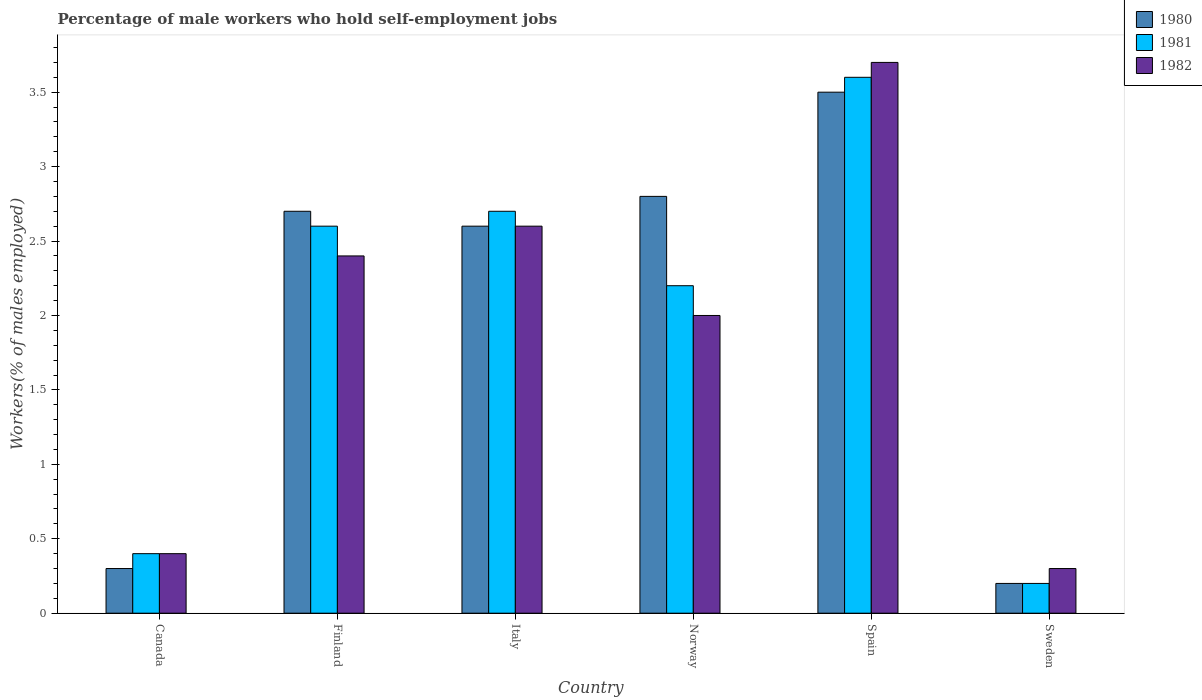How many groups of bars are there?
Offer a very short reply. 6. How many bars are there on the 2nd tick from the left?
Give a very brief answer. 3. How many bars are there on the 2nd tick from the right?
Offer a very short reply. 3. What is the label of the 6th group of bars from the left?
Keep it short and to the point. Sweden. In how many cases, is the number of bars for a given country not equal to the number of legend labels?
Make the answer very short. 0. What is the percentage of self-employed male workers in 1982 in Sweden?
Provide a succinct answer. 0.3. Across all countries, what is the maximum percentage of self-employed male workers in 1982?
Offer a very short reply. 3.7. Across all countries, what is the minimum percentage of self-employed male workers in 1981?
Provide a succinct answer. 0.2. In which country was the percentage of self-employed male workers in 1981 minimum?
Provide a succinct answer. Sweden. What is the total percentage of self-employed male workers in 1982 in the graph?
Make the answer very short. 11.4. What is the average percentage of self-employed male workers in 1982 per country?
Offer a very short reply. 1.9. What is the difference between the percentage of self-employed male workers of/in 1982 and percentage of self-employed male workers of/in 1980 in Sweden?
Your answer should be compact. 0.1. In how many countries, is the percentage of self-employed male workers in 1980 greater than 3.6 %?
Offer a terse response. 0. What is the ratio of the percentage of self-employed male workers in 1982 in Italy to that in Spain?
Provide a succinct answer. 0.7. What is the difference between the highest and the second highest percentage of self-employed male workers in 1980?
Give a very brief answer. -0.1. What is the difference between the highest and the lowest percentage of self-employed male workers in 1980?
Your answer should be very brief. 3.3. In how many countries, is the percentage of self-employed male workers in 1982 greater than the average percentage of self-employed male workers in 1982 taken over all countries?
Keep it short and to the point. 4. Is the sum of the percentage of self-employed male workers in 1982 in Finland and Norway greater than the maximum percentage of self-employed male workers in 1981 across all countries?
Make the answer very short. Yes. What does the 1st bar from the left in Sweden represents?
Your answer should be compact. 1980. What does the 2nd bar from the right in Spain represents?
Give a very brief answer. 1981. Is it the case that in every country, the sum of the percentage of self-employed male workers in 1982 and percentage of self-employed male workers in 1981 is greater than the percentage of self-employed male workers in 1980?
Provide a succinct answer. Yes. How many bars are there?
Make the answer very short. 18. What is the difference between two consecutive major ticks on the Y-axis?
Your answer should be compact. 0.5. Are the values on the major ticks of Y-axis written in scientific E-notation?
Make the answer very short. No. How many legend labels are there?
Provide a short and direct response. 3. What is the title of the graph?
Offer a very short reply. Percentage of male workers who hold self-employment jobs. Does "1962" appear as one of the legend labels in the graph?
Provide a succinct answer. No. What is the label or title of the Y-axis?
Provide a succinct answer. Workers(% of males employed). What is the Workers(% of males employed) of 1980 in Canada?
Your answer should be compact. 0.3. What is the Workers(% of males employed) of 1981 in Canada?
Your answer should be very brief. 0.4. What is the Workers(% of males employed) of 1982 in Canada?
Give a very brief answer. 0.4. What is the Workers(% of males employed) of 1980 in Finland?
Your response must be concise. 2.7. What is the Workers(% of males employed) of 1981 in Finland?
Your answer should be very brief. 2.6. What is the Workers(% of males employed) of 1982 in Finland?
Offer a very short reply. 2.4. What is the Workers(% of males employed) in 1980 in Italy?
Make the answer very short. 2.6. What is the Workers(% of males employed) in 1981 in Italy?
Offer a terse response. 2.7. What is the Workers(% of males employed) in 1982 in Italy?
Provide a succinct answer. 2.6. What is the Workers(% of males employed) in 1980 in Norway?
Offer a very short reply. 2.8. What is the Workers(% of males employed) in 1981 in Norway?
Provide a short and direct response. 2.2. What is the Workers(% of males employed) of 1982 in Norway?
Give a very brief answer. 2. What is the Workers(% of males employed) of 1981 in Spain?
Provide a succinct answer. 3.6. What is the Workers(% of males employed) in 1982 in Spain?
Your answer should be very brief. 3.7. What is the Workers(% of males employed) in 1980 in Sweden?
Provide a short and direct response. 0.2. What is the Workers(% of males employed) of 1981 in Sweden?
Provide a short and direct response. 0.2. What is the Workers(% of males employed) in 1982 in Sweden?
Make the answer very short. 0.3. Across all countries, what is the maximum Workers(% of males employed) in 1980?
Your answer should be compact. 3.5. Across all countries, what is the maximum Workers(% of males employed) of 1981?
Ensure brevity in your answer.  3.6. Across all countries, what is the maximum Workers(% of males employed) in 1982?
Make the answer very short. 3.7. Across all countries, what is the minimum Workers(% of males employed) of 1980?
Make the answer very short. 0.2. Across all countries, what is the minimum Workers(% of males employed) of 1981?
Offer a very short reply. 0.2. Across all countries, what is the minimum Workers(% of males employed) of 1982?
Your answer should be very brief. 0.3. What is the total Workers(% of males employed) in 1981 in the graph?
Make the answer very short. 11.7. What is the difference between the Workers(% of males employed) of 1981 in Canada and that in Norway?
Ensure brevity in your answer.  -1.8. What is the difference between the Workers(% of males employed) in 1980 in Canada and that in Spain?
Make the answer very short. -3.2. What is the difference between the Workers(% of males employed) in 1980 in Canada and that in Sweden?
Provide a succinct answer. 0.1. What is the difference between the Workers(% of males employed) in 1981 in Canada and that in Sweden?
Your response must be concise. 0.2. What is the difference between the Workers(% of males employed) in 1980 in Finland and that in Italy?
Ensure brevity in your answer.  0.1. What is the difference between the Workers(% of males employed) in 1981 in Finland and that in Italy?
Give a very brief answer. -0.1. What is the difference between the Workers(% of males employed) in 1982 in Finland and that in Italy?
Your answer should be very brief. -0.2. What is the difference between the Workers(% of males employed) in 1981 in Finland and that in Spain?
Provide a short and direct response. -1. What is the difference between the Workers(% of males employed) of 1980 in Finland and that in Sweden?
Keep it short and to the point. 2.5. What is the difference between the Workers(% of males employed) of 1981 in Italy and that in Spain?
Provide a short and direct response. -0.9. What is the difference between the Workers(% of males employed) of 1982 in Italy and that in Spain?
Provide a succinct answer. -1.1. What is the difference between the Workers(% of males employed) in 1982 in Italy and that in Sweden?
Provide a succinct answer. 2.3. What is the difference between the Workers(% of males employed) of 1980 in Norway and that in Spain?
Your answer should be compact. -0.7. What is the difference between the Workers(% of males employed) in 1981 in Norway and that in Spain?
Ensure brevity in your answer.  -1.4. What is the difference between the Workers(% of males employed) in 1982 in Norway and that in Spain?
Offer a very short reply. -1.7. What is the difference between the Workers(% of males employed) of 1982 in Norway and that in Sweden?
Keep it short and to the point. 1.7. What is the difference between the Workers(% of males employed) in 1980 in Spain and that in Sweden?
Make the answer very short. 3.3. What is the difference between the Workers(% of males employed) of 1981 in Spain and that in Sweden?
Ensure brevity in your answer.  3.4. What is the difference between the Workers(% of males employed) of 1982 in Spain and that in Sweden?
Your answer should be compact. 3.4. What is the difference between the Workers(% of males employed) in 1980 in Canada and the Workers(% of males employed) in 1981 in Finland?
Keep it short and to the point. -2.3. What is the difference between the Workers(% of males employed) of 1980 in Canada and the Workers(% of males employed) of 1981 in Italy?
Your answer should be very brief. -2.4. What is the difference between the Workers(% of males employed) in 1980 in Canada and the Workers(% of males employed) in 1981 in Norway?
Your answer should be compact. -1.9. What is the difference between the Workers(% of males employed) of 1981 in Canada and the Workers(% of males employed) of 1982 in Norway?
Make the answer very short. -1.6. What is the difference between the Workers(% of males employed) of 1980 in Canada and the Workers(% of males employed) of 1982 in Spain?
Keep it short and to the point. -3.4. What is the difference between the Workers(% of males employed) in 1981 in Canada and the Workers(% of males employed) in 1982 in Spain?
Your answer should be very brief. -3.3. What is the difference between the Workers(% of males employed) of 1980 in Canada and the Workers(% of males employed) of 1981 in Sweden?
Keep it short and to the point. 0.1. What is the difference between the Workers(% of males employed) of 1980 in Finland and the Workers(% of males employed) of 1982 in Italy?
Offer a terse response. 0.1. What is the difference between the Workers(% of males employed) in 1981 in Finland and the Workers(% of males employed) in 1982 in Italy?
Your answer should be very brief. 0. What is the difference between the Workers(% of males employed) in 1980 in Finland and the Workers(% of males employed) in 1981 in Norway?
Your answer should be compact. 0.5. What is the difference between the Workers(% of males employed) of 1980 in Finland and the Workers(% of males employed) of 1982 in Norway?
Offer a very short reply. 0.7. What is the difference between the Workers(% of males employed) of 1981 in Finland and the Workers(% of males employed) of 1982 in Norway?
Ensure brevity in your answer.  0.6. What is the difference between the Workers(% of males employed) in 1980 in Finland and the Workers(% of males employed) in 1981 in Sweden?
Your response must be concise. 2.5. What is the difference between the Workers(% of males employed) of 1980 in Finland and the Workers(% of males employed) of 1982 in Sweden?
Offer a very short reply. 2.4. What is the difference between the Workers(% of males employed) in 1980 in Italy and the Workers(% of males employed) in 1981 in Norway?
Give a very brief answer. 0.4. What is the difference between the Workers(% of males employed) in 1981 in Italy and the Workers(% of males employed) in 1982 in Norway?
Your response must be concise. 0.7. What is the difference between the Workers(% of males employed) in 1980 in Italy and the Workers(% of males employed) in 1981 in Spain?
Offer a terse response. -1. What is the difference between the Workers(% of males employed) of 1981 in Italy and the Workers(% of males employed) of 1982 in Spain?
Your answer should be compact. -1. What is the difference between the Workers(% of males employed) of 1980 in Norway and the Workers(% of males employed) of 1982 in Sweden?
Keep it short and to the point. 2.5. What is the difference between the Workers(% of males employed) in 1980 in Spain and the Workers(% of males employed) in 1981 in Sweden?
Offer a terse response. 3.3. What is the difference between the Workers(% of males employed) in 1980 in Spain and the Workers(% of males employed) in 1982 in Sweden?
Ensure brevity in your answer.  3.2. What is the difference between the Workers(% of males employed) of 1981 in Spain and the Workers(% of males employed) of 1982 in Sweden?
Give a very brief answer. 3.3. What is the average Workers(% of males employed) in 1980 per country?
Ensure brevity in your answer.  2.02. What is the average Workers(% of males employed) in 1981 per country?
Ensure brevity in your answer.  1.95. What is the difference between the Workers(% of males employed) in 1981 and Workers(% of males employed) in 1982 in Canada?
Your answer should be compact. 0. What is the difference between the Workers(% of males employed) in 1981 and Workers(% of males employed) in 1982 in Finland?
Provide a short and direct response. 0.2. What is the difference between the Workers(% of males employed) in 1980 and Workers(% of males employed) in 1982 in Italy?
Your answer should be compact. 0. What is the difference between the Workers(% of males employed) in 1981 and Workers(% of males employed) in 1982 in Italy?
Offer a very short reply. 0.1. What is the difference between the Workers(% of males employed) in 1981 and Workers(% of males employed) in 1982 in Norway?
Provide a succinct answer. 0.2. What is the difference between the Workers(% of males employed) of 1980 and Workers(% of males employed) of 1981 in Spain?
Offer a terse response. -0.1. What is the difference between the Workers(% of males employed) of 1980 and Workers(% of males employed) of 1982 in Spain?
Your answer should be compact. -0.2. What is the difference between the Workers(% of males employed) in 1981 and Workers(% of males employed) in 1982 in Sweden?
Your response must be concise. -0.1. What is the ratio of the Workers(% of males employed) in 1981 in Canada to that in Finland?
Offer a terse response. 0.15. What is the ratio of the Workers(% of males employed) in 1982 in Canada to that in Finland?
Offer a terse response. 0.17. What is the ratio of the Workers(% of males employed) of 1980 in Canada to that in Italy?
Provide a succinct answer. 0.12. What is the ratio of the Workers(% of males employed) of 1981 in Canada to that in Italy?
Your answer should be compact. 0.15. What is the ratio of the Workers(% of males employed) in 1982 in Canada to that in Italy?
Make the answer very short. 0.15. What is the ratio of the Workers(% of males employed) in 1980 in Canada to that in Norway?
Offer a very short reply. 0.11. What is the ratio of the Workers(% of males employed) in 1981 in Canada to that in Norway?
Your response must be concise. 0.18. What is the ratio of the Workers(% of males employed) of 1980 in Canada to that in Spain?
Offer a terse response. 0.09. What is the ratio of the Workers(% of males employed) in 1982 in Canada to that in Spain?
Give a very brief answer. 0.11. What is the ratio of the Workers(% of males employed) in 1980 in Finland to that in Italy?
Make the answer very short. 1.04. What is the ratio of the Workers(% of males employed) in 1981 in Finland to that in Italy?
Offer a terse response. 0.96. What is the ratio of the Workers(% of males employed) of 1982 in Finland to that in Italy?
Keep it short and to the point. 0.92. What is the ratio of the Workers(% of males employed) in 1980 in Finland to that in Norway?
Provide a succinct answer. 0.96. What is the ratio of the Workers(% of males employed) of 1981 in Finland to that in Norway?
Your response must be concise. 1.18. What is the ratio of the Workers(% of males employed) in 1980 in Finland to that in Spain?
Ensure brevity in your answer.  0.77. What is the ratio of the Workers(% of males employed) of 1981 in Finland to that in Spain?
Make the answer very short. 0.72. What is the ratio of the Workers(% of males employed) of 1982 in Finland to that in Spain?
Your answer should be compact. 0.65. What is the ratio of the Workers(% of males employed) of 1980 in Italy to that in Norway?
Keep it short and to the point. 0.93. What is the ratio of the Workers(% of males employed) in 1981 in Italy to that in Norway?
Provide a succinct answer. 1.23. What is the ratio of the Workers(% of males employed) in 1982 in Italy to that in Norway?
Provide a succinct answer. 1.3. What is the ratio of the Workers(% of males employed) of 1980 in Italy to that in Spain?
Offer a very short reply. 0.74. What is the ratio of the Workers(% of males employed) of 1981 in Italy to that in Spain?
Provide a short and direct response. 0.75. What is the ratio of the Workers(% of males employed) in 1982 in Italy to that in Spain?
Your answer should be compact. 0.7. What is the ratio of the Workers(% of males employed) in 1982 in Italy to that in Sweden?
Provide a short and direct response. 8.67. What is the ratio of the Workers(% of males employed) in 1980 in Norway to that in Spain?
Your answer should be compact. 0.8. What is the ratio of the Workers(% of males employed) of 1981 in Norway to that in Spain?
Your answer should be compact. 0.61. What is the ratio of the Workers(% of males employed) of 1982 in Norway to that in Spain?
Provide a short and direct response. 0.54. What is the ratio of the Workers(% of males employed) of 1980 in Norway to that in Sweden?
Offer a very short reply. 14. What is the ratio of the Workers(% of males employed) of 1982 in Norway to that in Sweden?
Give a very brief answer. 6.67. What is the ratio of the Workers(% of males employed) in 1981 in Spain to that in Sweden?
Provide a succinct answer. 18. What is the ratio of the Workers(% of males employed) in 1982 in Spain to that in Sweden?
Make the answer very short. 12.33. What is the difference between the highest and the second highest Workers(% of males employed) in 1981?
Your answer should be compact. 0.9. What is the difference between the highest and the lowest Workers(% of males employed) in 1981?
Provide a succinct answer. 3.4. 